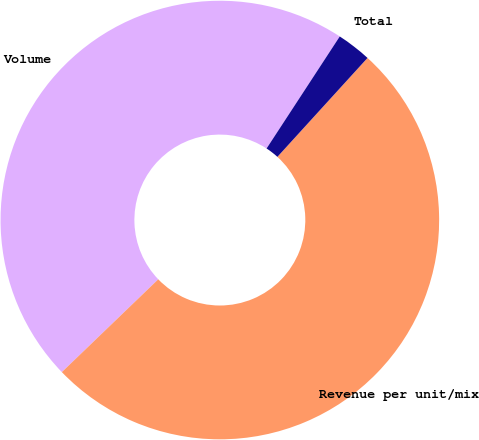<chart> <loc_0><loc_0><loc_500><loc_500><pie_chart><fcel>Volume<fcel>Revenue per unit/mix<fcel>Total<nl><fcel>46.4%<fcel>51.04%<fcel>2.55%<nl></chart> 